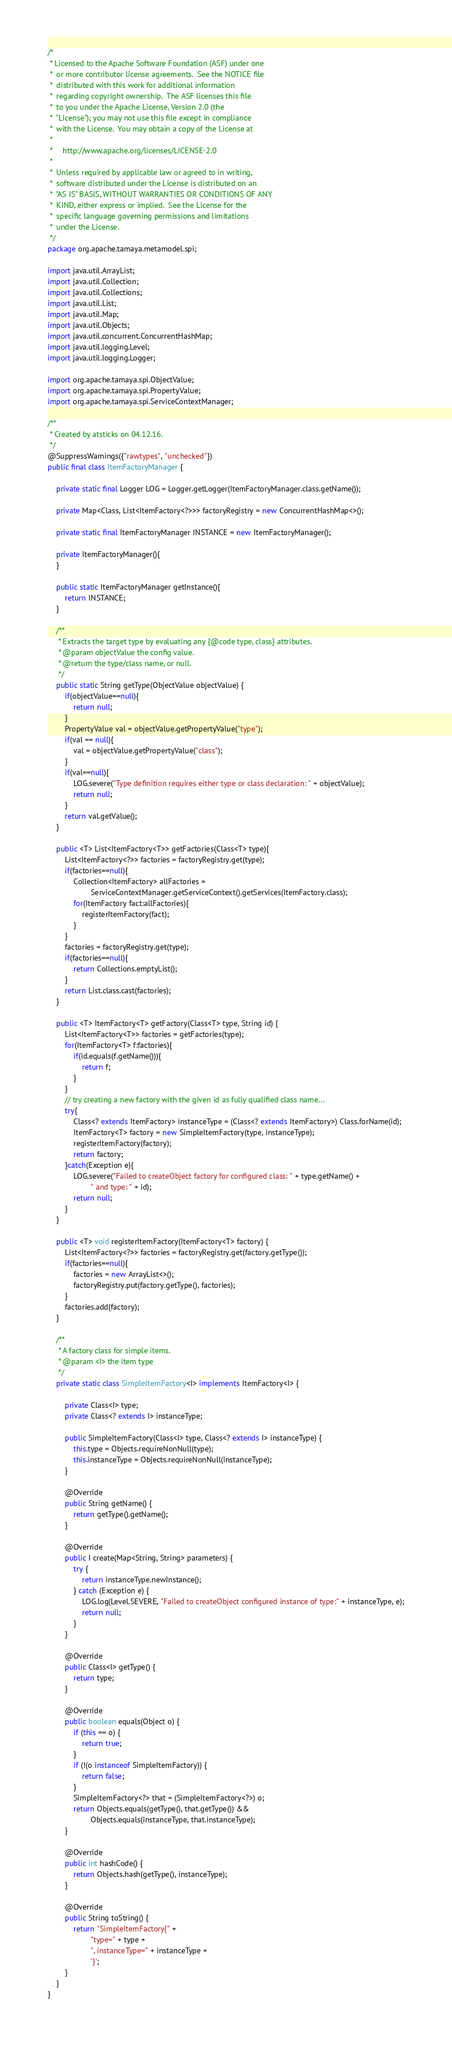Convert code to text. <code><loc_0><loc_0><loc_500><loc_500><_Java_>/*
 * Licensed to the Apache Software Foundation (ASF) under one
 *  or more contributor license agreements.  See the NOTICE file
 *  distributed with this work for additional information
 *  regarding copyright ownership.  The ASF licenses this file
 *  to you under the Apache License, Version 2.0 (the
 *  "License"); you may not use this file except in compliance
 *  with the License.  You may obtain a copy of the License at
 *
 *     http://www.apache.org/licenses/LICENSE-2.0
 *
 *  Unless required by applicable law or agreed to in writing,
 *  software distributed under the License is distributed on an
 *  "AS IS" BASIS, WITHOUT WARRANTIES OR CONDITIONS OF ANY
 *  KIND, either express or implied.  See the License for the
 *  specific language governing permissions and limitations
 *  under the License.
 */
package org.apache.tamaya.metamodel.spi;

import java.util.ArrayList;
import java.util.Collection;
import java.util.Collections;
import java.util.List;
import java.util.Map;
import java.util.Objects;
import java.util.concurrent.ConcurrentHashMap;
import java.util.logging.Level;
import java.util.logging.Logger;

import org.apache.tamaya.spi.ObjectValue;
import org.apache.tamaya.spi.PropertyValue;
import org.apache.tamaya.spi.ServiceContextManager;

/**
 * Created by atsticks on 04.12.16.
 */
@SuppressWarnings({"rawtypes", "unchecked"})
public final class ItemFactoryManager {

    private static final Logger LOG = Logger.getLogger(ItemFactoryManager.class.getName());

    private Map<Class, List<ItemFactory<?>>> factoryRegistry = new ConcurrentHashMap<>();

    private static final ItemFactoryManager INSTANCE = new ItemFactoryManager();

    private ItemFactoryManager(){
    }

    public static ItemFactoryManager getInstance(){
        return INSTANCE;
    }

    /**
     * Extracts the target type by evaluating any {@code type, class} attributes.
     * @param objectValue the config value.
     * @return the type/class name, or null.
     */
    public static String getType(ObjectValue objectValue) {
        if(objectValue==null){
            return null;
        }
        PropertyValue val = objectValue.getPropertyValue("type");
        if(val == null){
            val = objectValue.getPropertyValue("class");
        }
        if(val==null){
            LOG.severe("Type definition requires either type or class declaration: " + objectValue);
            return null;
        }
        return val.getValue();
    }

    public <T> List<ItemFactory<T>> getFactories(Class<T> type){
        List<ItemFactory<?>> factories = factoryRegistry.get(type);
        if(factories==null){
            Collection<ItemFactory> allFactories =
                    ServiceContextManager.getServiceContext().getServices(ItemFactory.class);
            for(ItemFactory fact:allFactories){
                registerItemFactory(fact);
            }
        }
        factories = factoryRegistry.get(type);
        if(factories==null){
            return Collections.emptyList();
        }
        return List.class.cast(factories);
    }

    public <T> ItemFactory<T> getFactory(Class<T> type, String id) {
        List<ItemFactory<T>> factories = getFactories(type);
        for(ItemFactory<T> f:factories){
            if(id.equals(f.getName())){
                return f;
            }
        }
        // try creating a new factory with the given id as fully qualified class name...
        try{
            Class<? extends ItemFactory> instanceType = (Class<? extends ItemFactory>) Class.forName(id);
            ItemFactory<T> factory = new SimpleItemFactory(type, instanceType);
            registerItemFactory(factory);
            return factory;
        }catch(Exception e){
            LOG.severe("Failed to createObject factory for configured class: " + type.getName() +
                    " and type: " + id);
            return null;
        }
    }

    public <T> void registerItemFactory(ItemFactory<T> factory) {
        List<ItemFactory<?>> factories = factoryRegistry.get(factory.getType());
        if(factories==null){
            factories = new ArrayList<>();
            factoryRegistry.put(factory.getType(), factories);
        }
        factories.add(factory);
    }

    /**
     * A factory class for simple items.
     * @param <I> the item type
     */
    private static class SimpleItemFactory<I> implements ItemFactory<I> {

        private Class<I> type;
        private Class<? extends I> instanceType;

        public SimpleItemFactory(Class<I> type, Class<? extends I> instanceType) {
            this.type = Objects.requireNonNull(type);
            this.instanceType = Objects.requireNonNull(instanceType);
        }

        @Override
        public String getName() {
            return getType().getName();
        }

        @Override
        public I create(Map<String, String> parameters) {
            try {
                return instanceType.newInstance();
            } catch (Exception e) {
                LOG.log(Level.SEVERE, "Failed to createObject configured instance of type:" + instanceType, e);
                return null;
            }
        }

        @Override
        public Class<I> getType() {
            return type;
        }

        @Override
        public boolean equals(Object o) {
            if (this == o) {
                return true;
            }
            if (!(o instanceof SimpleItemFactory)) {
                return false;
            }
            SimpleItemFactory<?> that = (SimpleItemFactory<?>) o;
            return Objects.equals(getType(), that.getType()) &&
                    Objects.equals(instanceType, that.instanceType);
        }

        @Override
        public int hashCode() {
            return Objects.hash(getType(), instanceType);
        }

        @Override
        public String toString() {
            return "SimpleItemFactory{" +
                    "type=" + type +
                    ", instanceType=" + instanceType +
                    '}';
        }
    }
}
</code> 